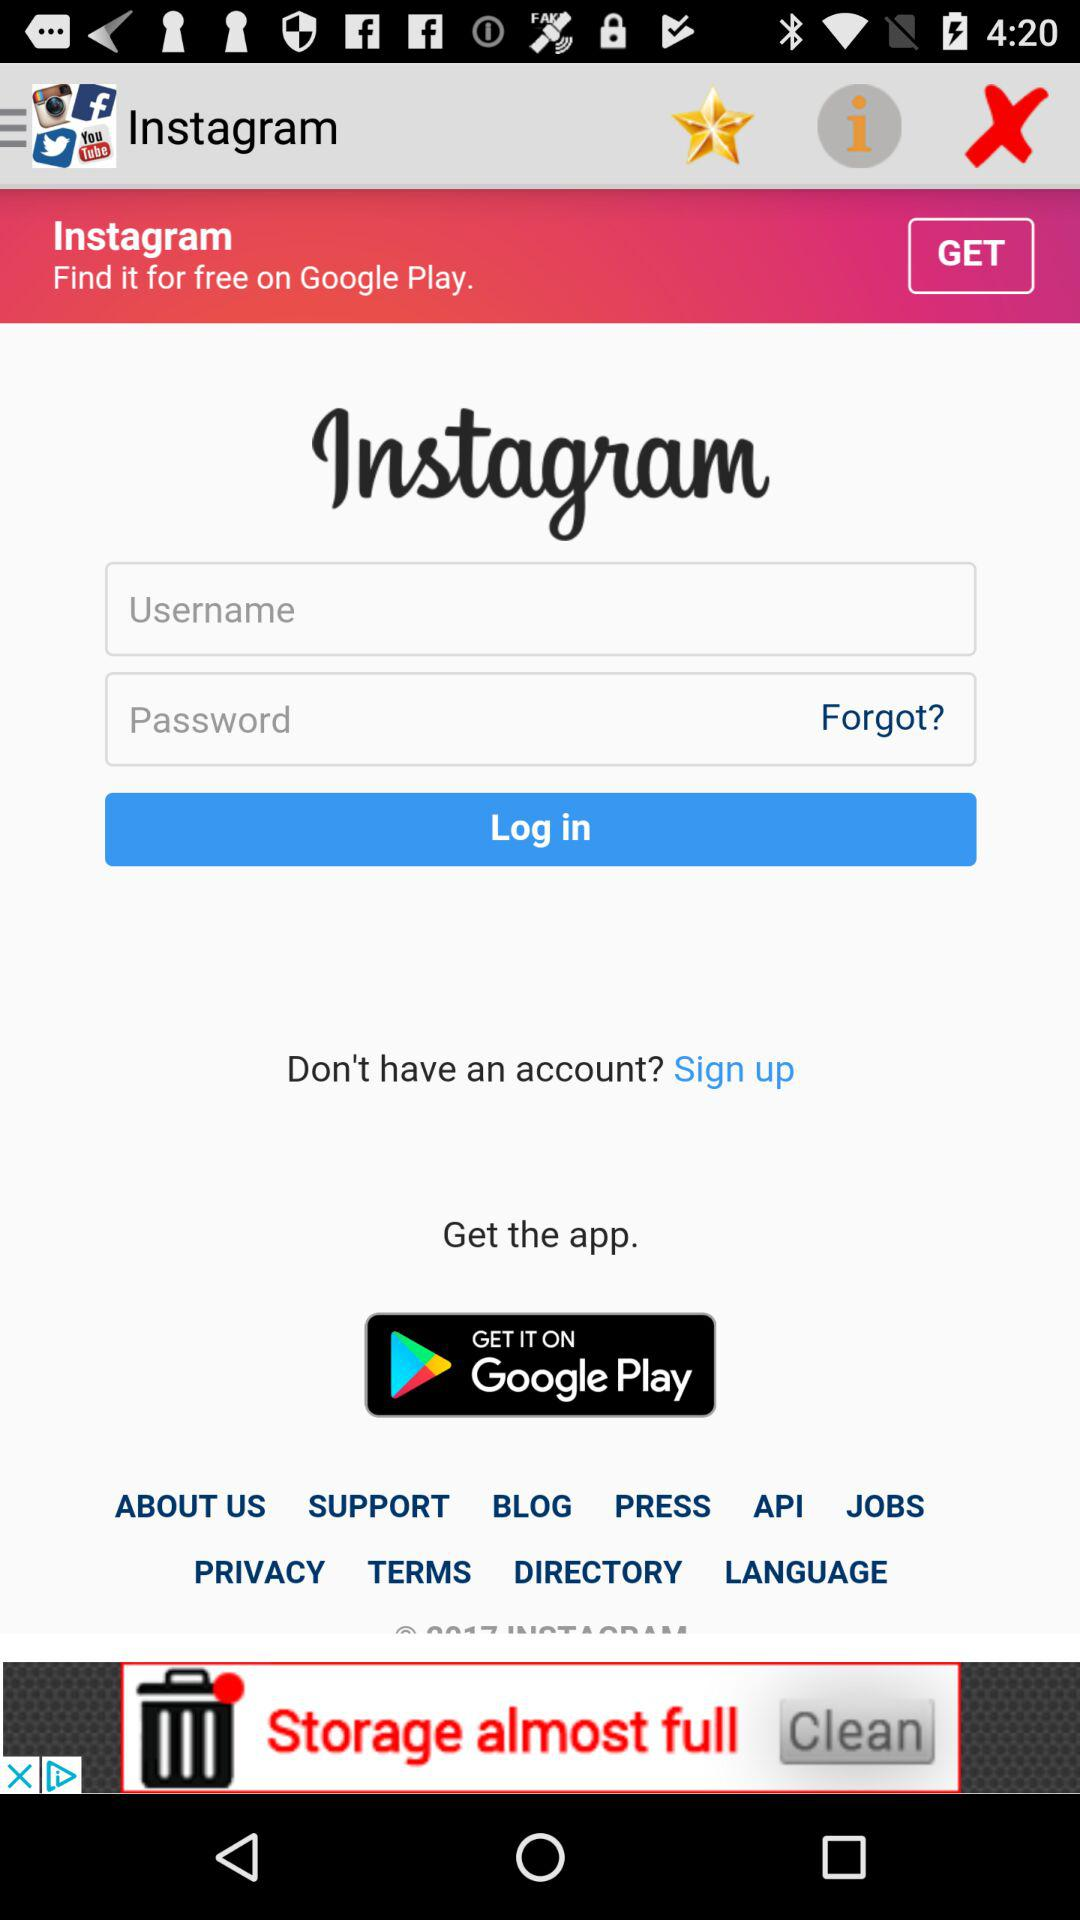What is the application name? The applications' names are "Instagram" and "Google Play". 